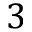<formula> <loc_0><loc_0><loc_500><loc_500>3</formula> 